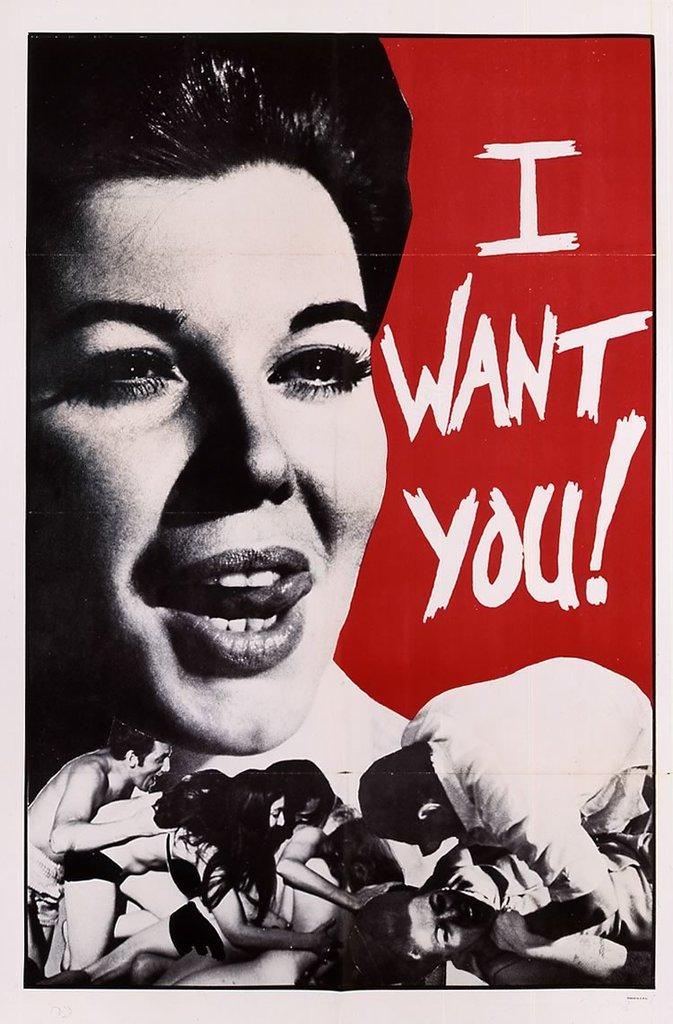Who do i want?
Your answer should be very brief. You. 